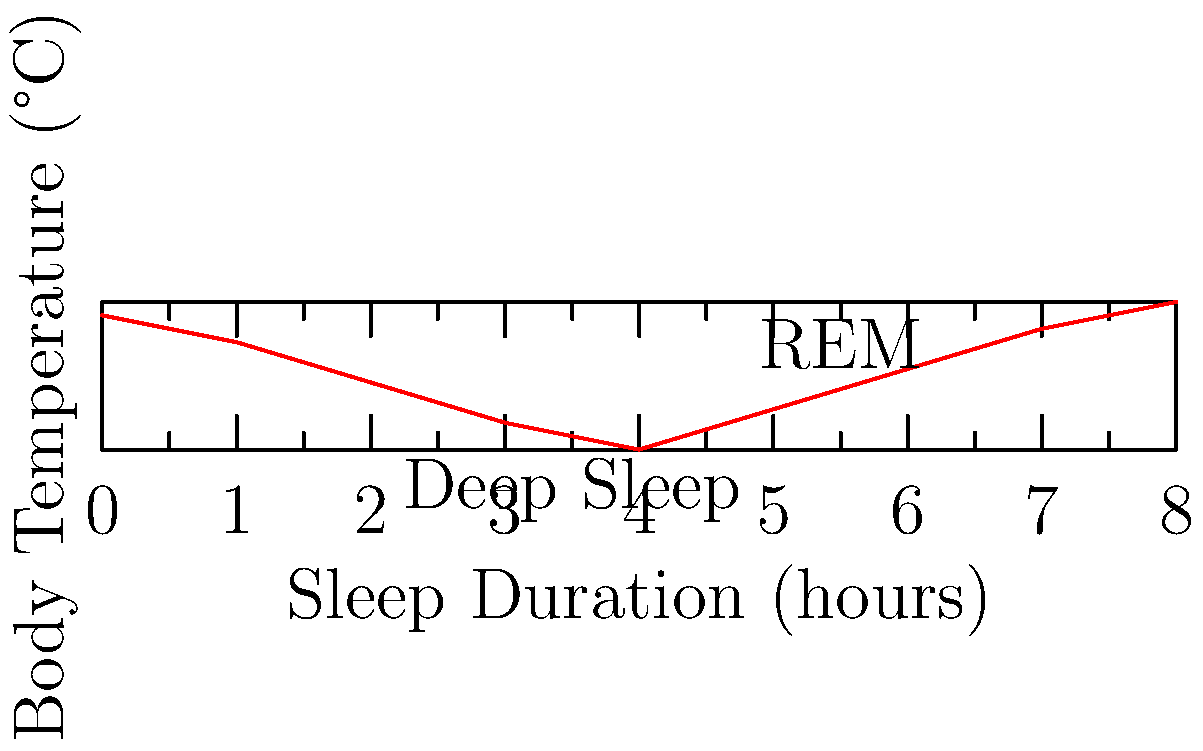The graph shows body temperature fluctuations during a typical 8-hour sleep cycle. Calculate the rate of temperature change (in °C/hour) during the first 4 hours of sleep. How might this temperature drop affect the body's energy consumption, and what holistic approaches could support this natural process? To solve this problem, we'll follow these steps:

1. Calculate the temperature change:
   Initial temperature (at 0 hours): $37.0°C$
   Temperature at 4 hours: $36.0°C$
   Change in temperature: $\Delta T = 36.0°C - 37.0°C = -1.0°C$

2. Calculate the rate of temperature change:
   Rate = Change in temperature / Time
   $\text{Rate} = \frac{\Delta T}{\Delta t} = \frac{-1.0°C}{4\text{ hours}} = -0.25°C/\text{hour}$

3. Energy consumption implications:
   The drop in body temperature during sleep is associated with reduced metabolic rate and energy conservation. This process is crucial for the body's repair and regeneration processes during sleep.

4. Holistic approaches to support this process:
   a) Maintain a cool sleeping environment (around 18-20°C) to facilitate the natural drop in body temperature.
   b) Practice relaxation techniques before bed to help initiate the temperature-lowering process.
   c) Use breathable, natural fiber bedding to assist in temperature regulation.
   d) Avoid heavy meals close to bedtime, as digestion can increase body temperature.
   e) Consider herbs like valerian root or chamomile tea, which may promote relaxation and support natural sleep processes.
   f) Implement a consistent sleep schedule to reinforce the body's natural circadian rhythm.

These approaches work synergistically with the body's natural temperature regulation during sleep, potentially enhancing sleep quality and overall health without relying on medication.
Answer: -0.25°C/hour; supports energy conservation and restoration; holistic approaches include cool environments, relaxation techniques, and proper sleep hygiene. 